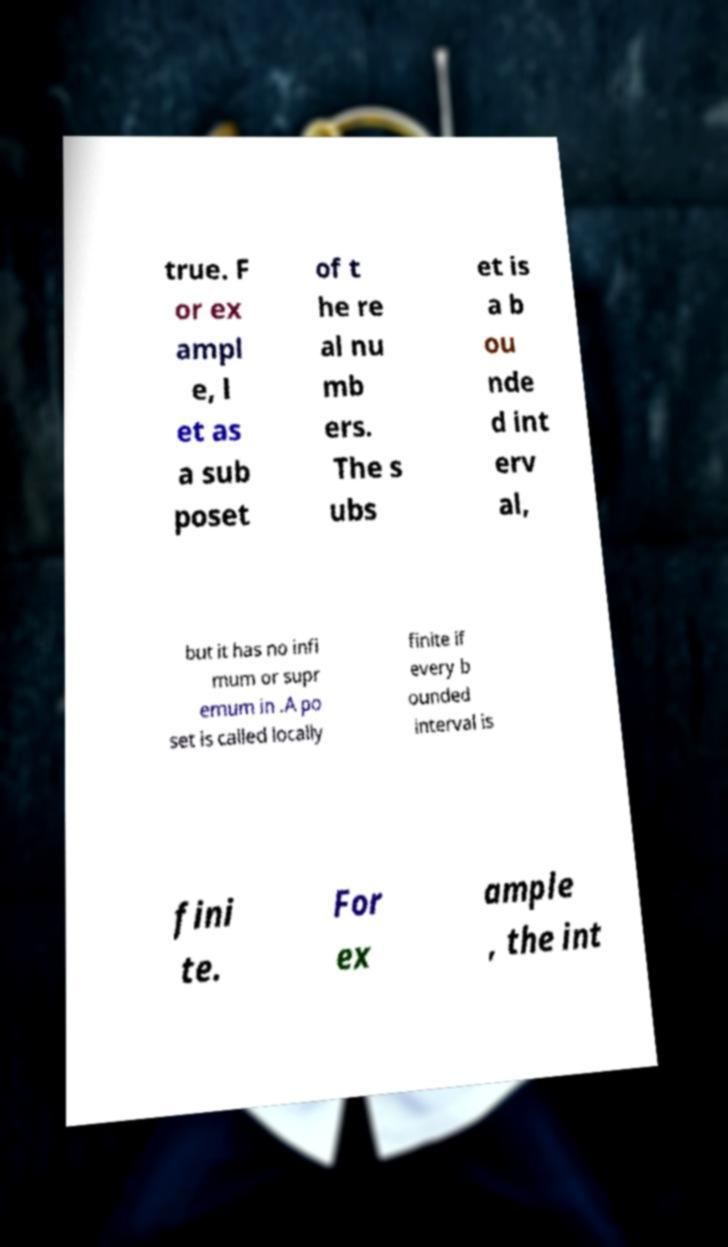There's text embedded in this image that I need extracted. Can you transcribe it verbatim? true. F or ex ampl e, l et as a sub poset of t he re al nu mb ers. The s ubs et is a b ou nde d int erv al, but it has no infi mum or supr emum in .A po set is called locally finite if every b ounded interval is fini te. For ex ample , the int 